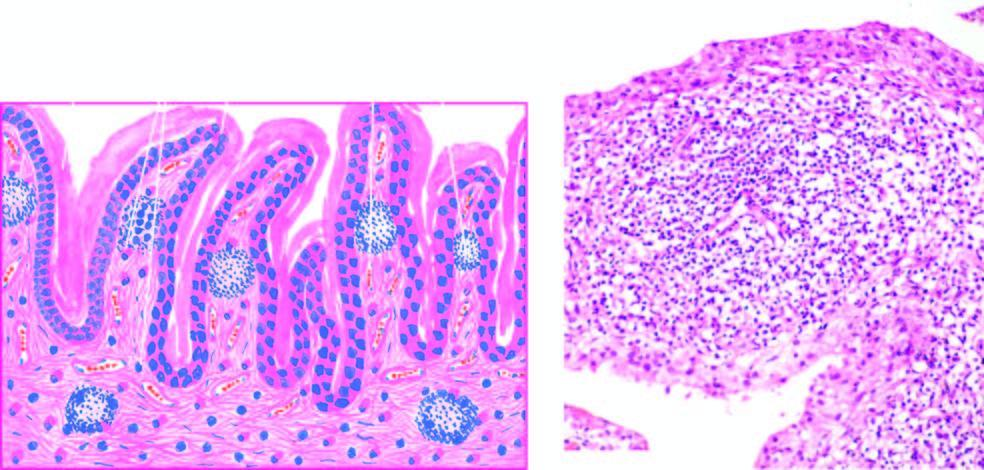what are villous hypertrophy of the synovium and marked mononuclear inflammatory cell infiltrate in synovial membrane with formation of lymphoid follicles at places?
Answer the question using a single word or phrase. Characteristic histologic features 